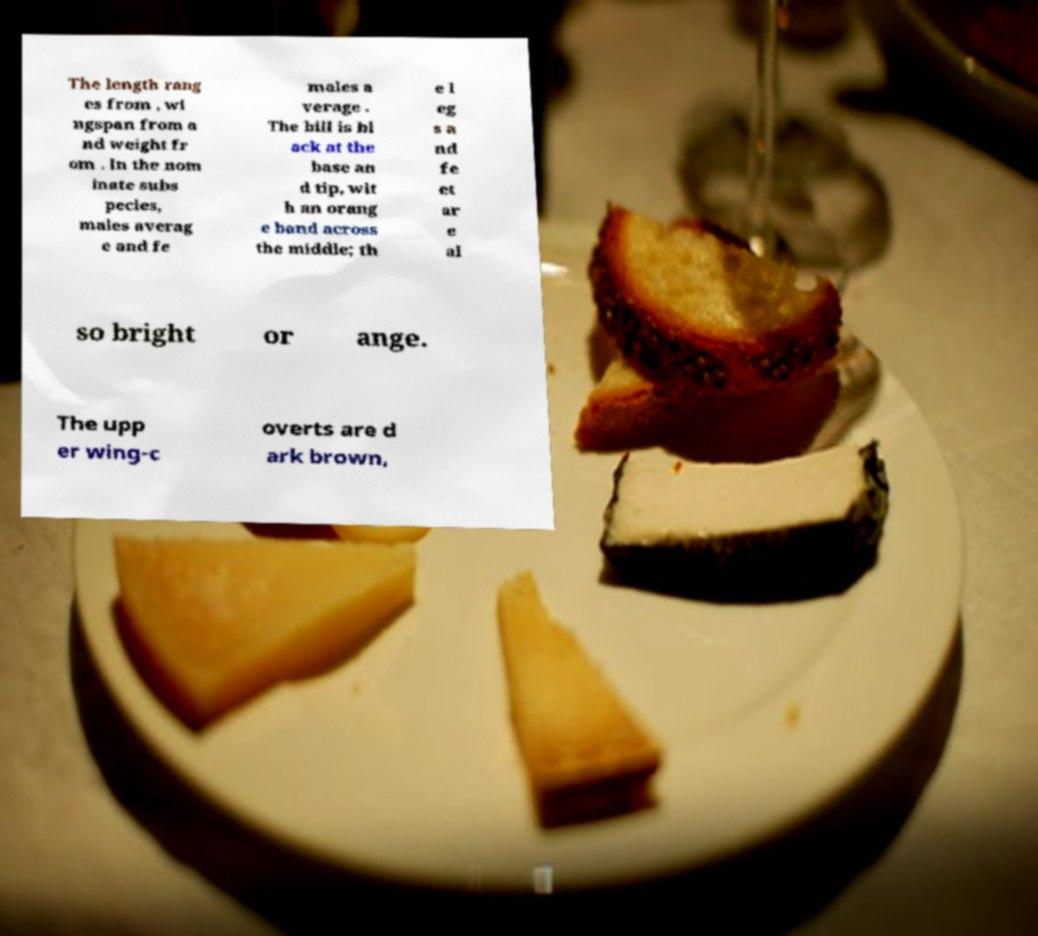Could you extract and type out the text from this image? The length rang es from , wi ngspan from a nd weight fr om . In the nom inate subs pecies, males averag e and fe males a verage . The bill is bl ack at the base an d tip, wit h an orang e band across the middle; th e l eg s a nd fe et ar e al so bright or ange. The upp er wing-c overts are d ark brown, 